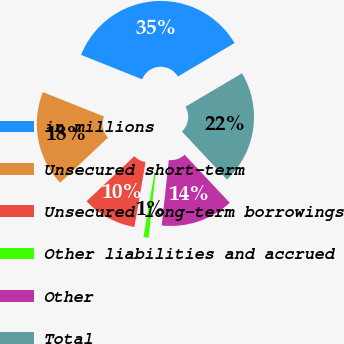Convert chart to OTSL. <chart><loc_0><loc_0><loc_500><loc_500><pie_chart><fcel>in millions<fcel>Unsecured short-term<fcel>Unsecured long-term borrowings<fcel>Other liabilities and accrued<fcel>Other<fcel>Total<nl><fcel>35.45%<fcel>18.08%<fcel>10.27%<fcel>0.97%<fcel>13.72%<fcel>21.52%<nl></chart> 